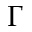Convert formula to latex. <formula><loc_0><loc_0><loc_500><loc_500>\Gamma</formula> 